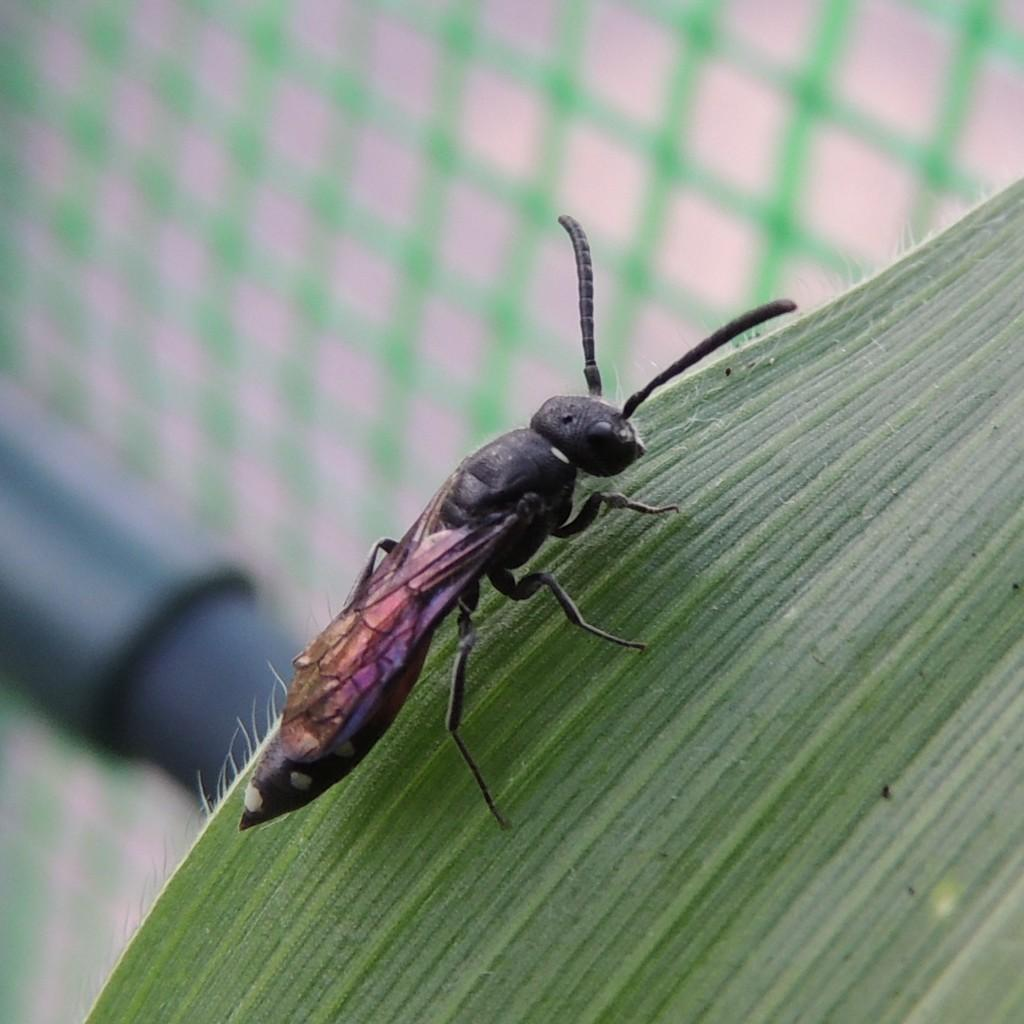What is the main subject of the image? There is an insect in the image. Where is the insect located? The insect is on a leaf. Can you describe the background of the image? The background of the image is blurred. What does the insect taste like in the image? The image does not provide any information about the taste of the insect, as it is a visual representation. 